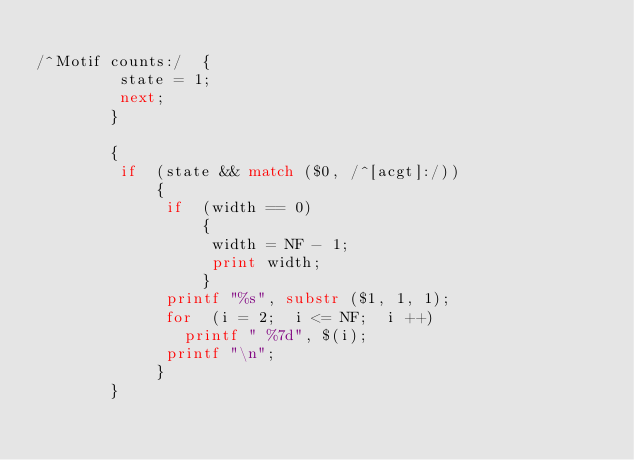<code> <loc_0><loc_0><loc_500><loc_500><_Awk_>
/^Motif counts:/  {
         state = 1;
         next;
        }

        {
         if  (state && match ($0, /^[acgt]:/))
             {
              if  (width == 0)
                  {
                   width = NF - 1;
                   print width;
                  }
              printf "%s", substr ($1, 1, 1);
              for  (i = 2;  i <= NF;  i ++)
                printf " %7d", $(i);
              printf "\n";
             }
        }


</code> 